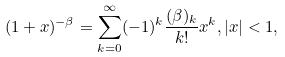<formula> <loc_0><loc_0><loc_500><loc_500>( 1 + x ) ^ { - \beta } = \sum _ { k = 0 } ^ { \infty } ( - 1 ) ^ { k } \frac { ( \beta ) _ { k } } { k ! } x ^ { k } , | x | < 1 ,</formula> 